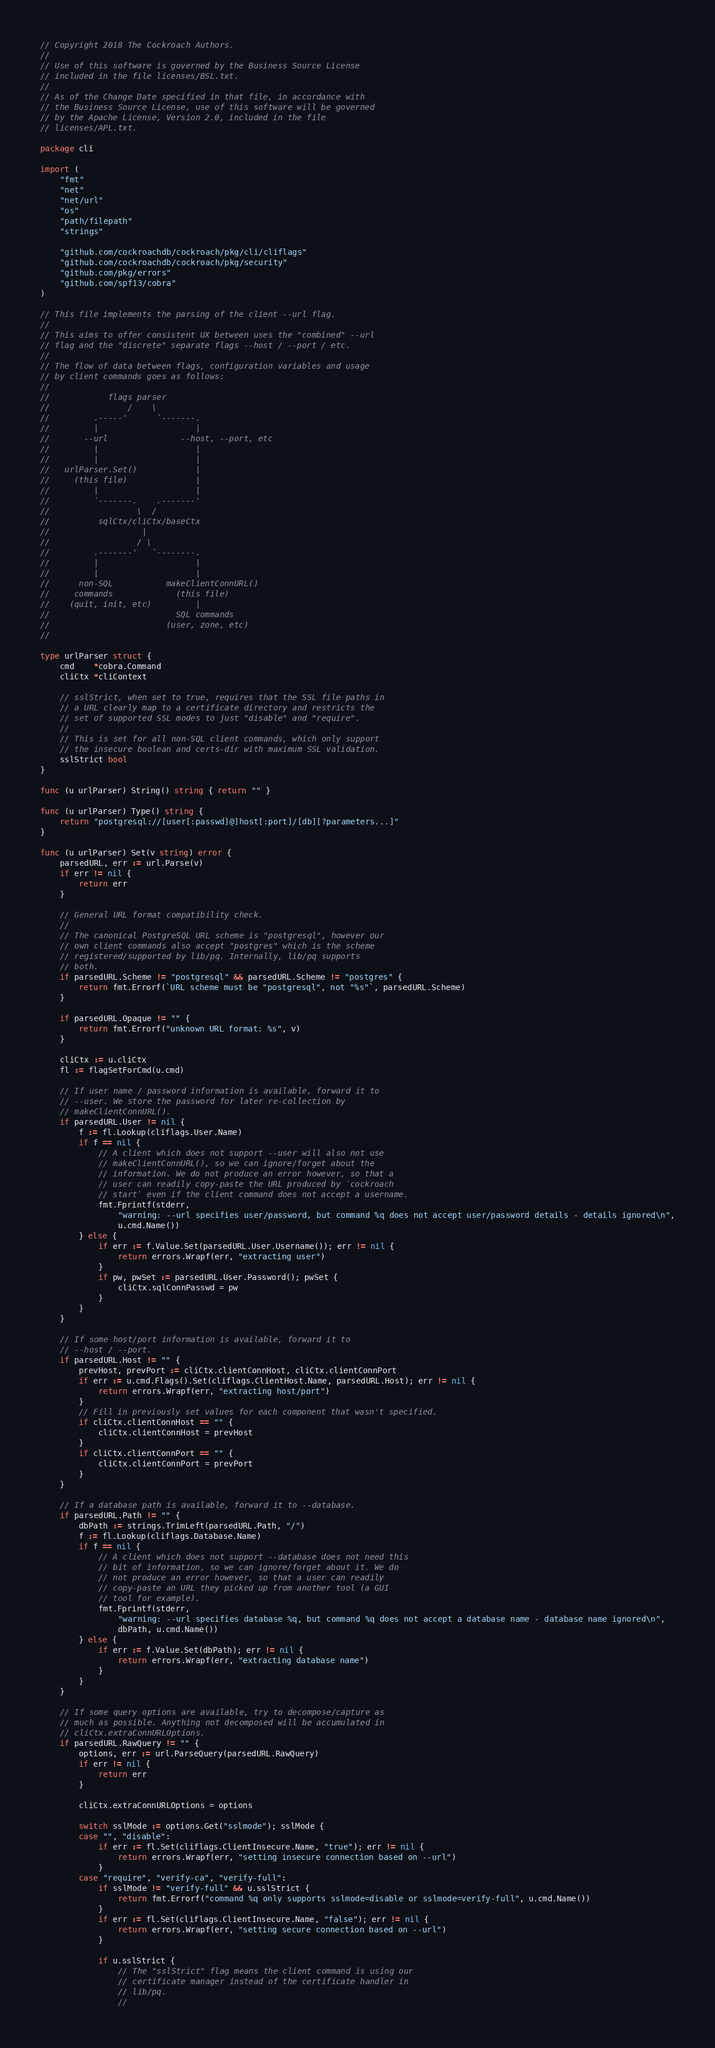<code> <loc_0><loc_0><loc_500><loc_500><_Go_>// Copyright 2018 The Cockroach Authors.
//
// Use of this software is governed by the Business Source License
// included in the file licenses/BSL.txt.
//
// As of the Change Date specified in that file, in accordance with
// the Business Source License, use of this software will be governed
// by the Apache License, Version 2.0, included in the file
// licenses/APL.txt.

package cli

import (
	"fmt"
	"net"
	"net/url"
	"os"
	"path/filepath"
	"strings"

	"github.com/cockroachdb/cockroach/pkg/cli/cliflags"
	"github.com/cockroachdb/cockroach/pkg/security"
	"github.com/pkg/errors"
	"github.com/spf13/cobra"
)

// This file implements the parsing of the client --url flag.
//
// This aims to offer consistent UX between uses the "combined" --url
// flag and the "discrete" separate flags --host / --port / etc.
//
// The flow of data between flags, configuration variables and usage
// by client commands goes as follows:
//
//            flags parser
//                /    \
//         .-----'      `-------.
//         |                    |
//       --url               --host, --port, etc
//         |                    |
//         |                    |
//   urlParser.Set()            |
//     (this file)              |
//         |                    |
//         `-------.    .-------'
//                  \  /
//          sqlCtx/cliCtx/baseCtx
//                   |
//                  / \
//         .-------'   `--------.
//         |                    |
//         |                    |
//      non-SQL           makeClientConnURL()
//     commands             (this file)
//    (quit, init, etc)         |
//                          SQL commands
//                        (user, zone, etc)
//

type urlParser struct {
	cmd    *cobra.Command
	cliCtx *cliContext

	// sslStrict, when set to true, requires that the SSL file paths in
	// a URL clearly map to a certificate directory and restricts the
	// set of supported SSL modes to just "disable" and "require".
	//
	// This is set for all non-SQL client commands, which only support
	// the insecure boolean and certs-dir with maximum SSL validation.
	sslStrict bool
}

func (u urlParser) String() string { return "" }

func (u urlParser) Type() string {
	return "postgresql://[user[:passwd]@]host[:port]/[db][?parameters...]"
}

func (u urlParser) Set(v string) error {
	parsedURL, err := url.Parse(v)
	if err != nil {
		return err
	}

	// General URL format compatibility check.
	//
	// The canonical PostgreSQL URL scheme is "postgresql", however our
	// own client commands also accept "postgres" which is the scheme
	// registered/supported by lib/pq. Internally, lib/pq supports
	// both.
	if parsedURL.Scheme != "postgresql" && parsedURL.Scheme != "postgres" {
		return fmt.Errorf(`URL scheme must be "postgresql", not "%s"`, parsedURL.Scheme)
	}

	if parsedURL.Opaque != "" {
		return fmt.Errorf("unknown URL format: %s", v)
	}

	cliCtx := u.cliCtx
	fl := flagSetForCmd(u.cmd)

	// If user name / password information is available, forward it to
	// --user. We store the password for later re-collection by
	// makeClientConnURL().
	if parsedURL.User != nil {
		f := fl.Lookup(cliflags.User.Name)
		if f == nil {
			// A client which does not support --user will also not use
			// makeClientConnURL(), so we can ignore/forget about the
			// information. We do not produce an error however, so that a
			// user can readily copy-paste the URL produced by `cockroach
			// start` even if the client command does not accept a username.
			fmt.Fprintf(stderr,
				"warning: --url specifies user/password, but command %q does not accept user/password details - details ignored\n",
				u.cmd.Name())
		} else {
			if err := f.Value.Set(parsedURL.User.Username()); err != nil {
				return errors.Wrapf(err, "extracting user")
			}
			if pw, pwSet := parsedURL.User.Password(); pwSet {
				cliCtx.sqlConnPasswd = pw
			}
		}
	}

	// If some host/port information is available, forward it to
	// --host / --port.
	if parsedURL.Host != "" {
		prevHost, prevPort := cliCtx.clientConnHost, cliCtx.clientConnPort
		if err := u.cmd.Flags().Set(cliflags.ClientHost.Name, parsedURL.Host); err != nil {
			return errors.Wrapf(err, "extracting host/port")
		}
		// Fill in previously set values for each component that wasn't specified.
		if cliCtx.clientConnHost == "" {
			cliCtx.clientConnHost = prevHost
		}
		if cliCtx.clientConnPort == "" {
			cliCtx.clientConnPort = prevPort
		}
	}

	// If a database path is available, forward it to --database.
	if parsedURL.Path != "" {
		dbPath := strings.TrimLeft(parsedURL.Path, "/")
		f := fl.Lookup(cliflags.Database.Name)
		if f == nil {
			// A client which does not support --database does not need this
			// bit of information, so we can ignore/forget about it. We do
			// not produce an error however, so that a user can readily
			// copy-paste an URL they picked up from another tool (a GUI
			// tool for example).
			fmt.Fprintf(stderr,
				"warning: --url specifies database %q, but command %q does not accept a database name - database name ignored\n",
				dbPath, u.cmd.Name())
		} else {
			if err := f.Value.Set(dbPath); err != nil {
				return errors.Wrapf(err, "extracting database name")
			}
		}
	}

	// If some query options are available, try to decompose/capture as
	// much as possible. Anything not decomposed will be accumulated in
	// cliCtx.extraConnURLOptions.
	if parsedURL.RawQuery != "" {
		options, err := url.ParseQuery(parsedURL.RawQuery)
		if err != nil {
			return err
		}

		cliCtx.extraConnURLOptions = options

		switch sslMode := options.Get("sslmode"); sslMode {
		case "", "disable":
			if err := fl.Set(cliflags.ClientInsecure.Name, "true"); err != nil {
				return errors.Wrapf(err, "setting insecure connection based on --url")
			}
		case "require", "verify-ca", "verify-full":
			if sslMode != "verify-full" && u.sslStrict {
				return fmt.Errorf("command %q only supports sslmode=disable or sslmode=verify-full", u.cmd.Name())
			}
			if err := fl.Set(cliflags.ClientInsecure.Name, "false"); err != nil {
				return errors.Wrapf(err, "setting secure connection based on --url")
			}

			if u.sslStrict {
				// The "sslStrict" flag means the client command is using our
				// certificate manager instead of the certificate handler in
				// lib/pq.
				//</code> 